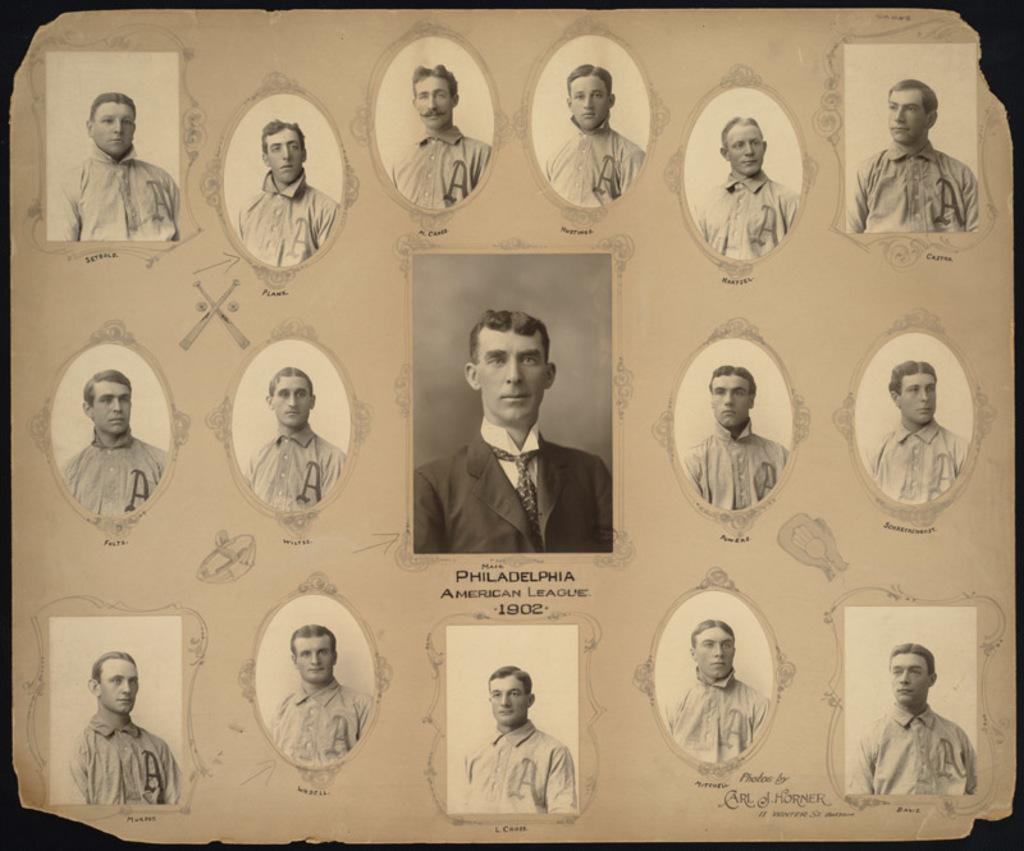What is present in the image? There is a paper in the image. What can be found on the paper? There are photos on the paper. What type of mine can be seen in the image? There is no mine present in the image; it only features a paper with photos on it. 